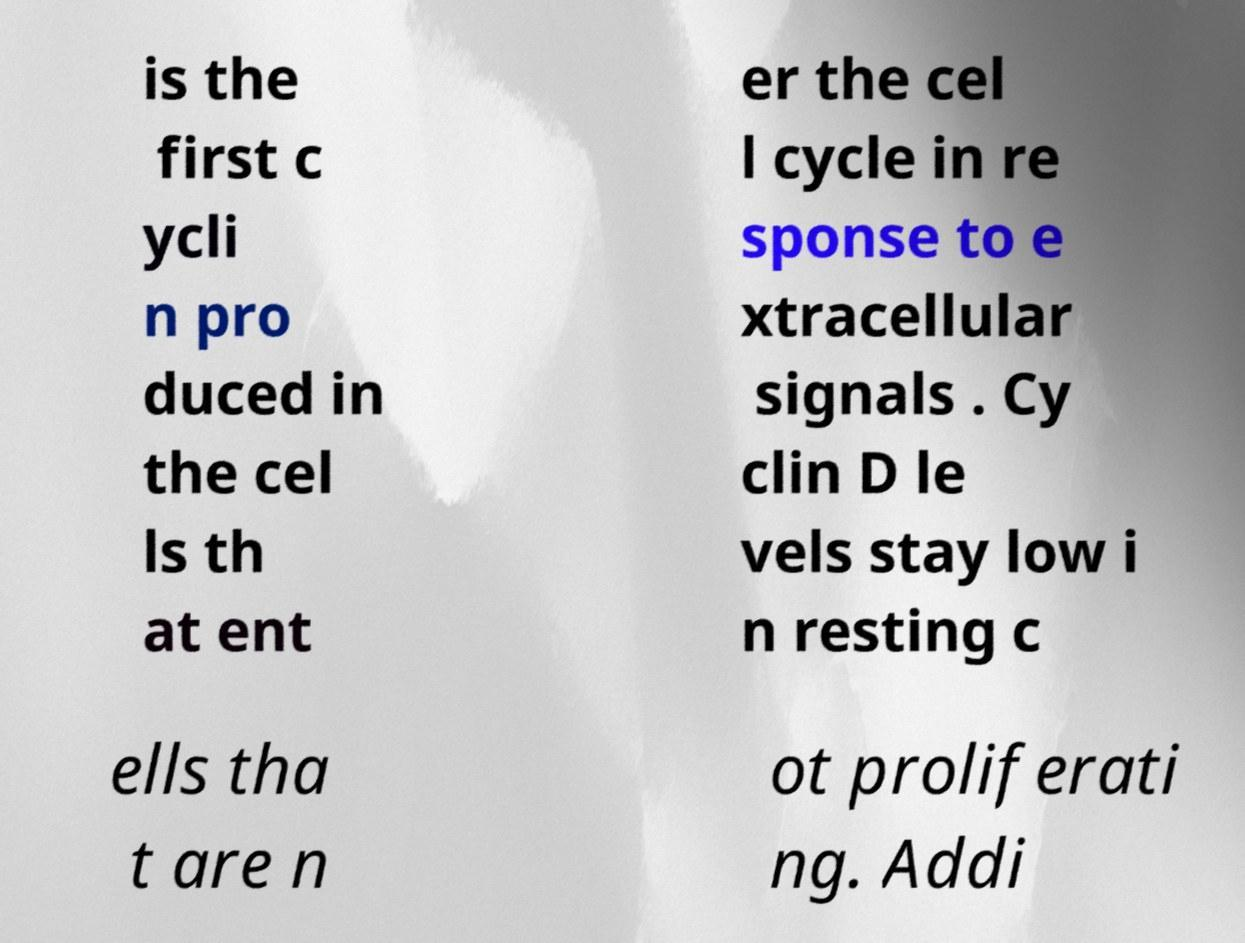Could you assist in decoding the text presented in this image and type it out clearly? is the first c ycli n pro duced in the cel ls th at ent er the cel l cycle in re sponse to e xtracellular signals . Cy clin D le vels stay low i n resting c ells tha t are n ot proliferati ng. Addi 